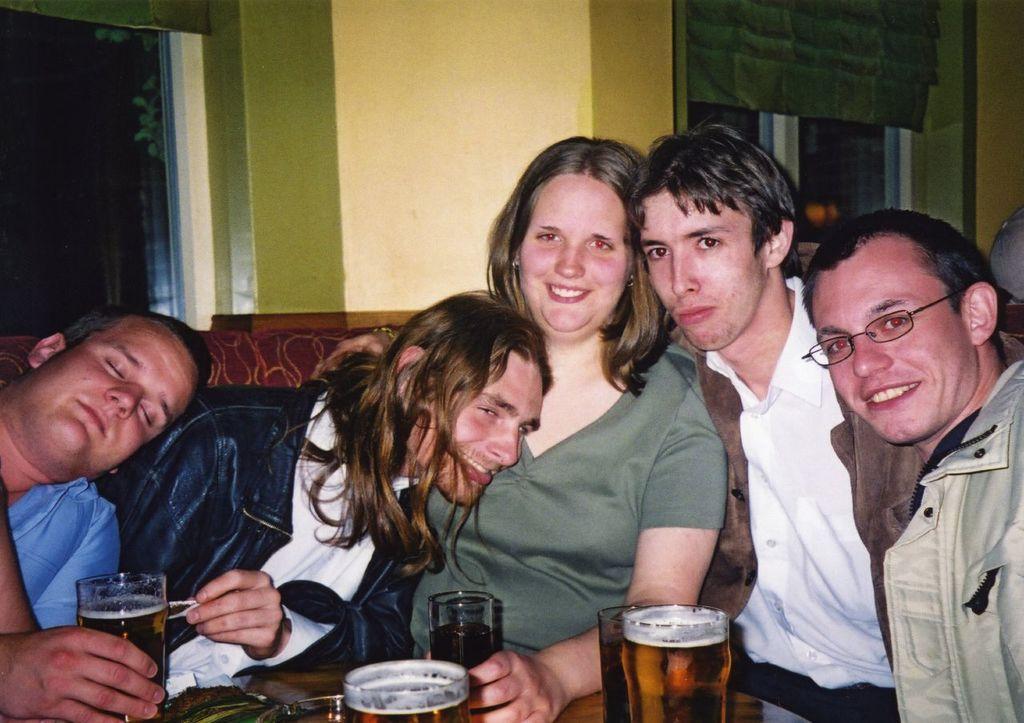Describe this image in one or two sentences. This picture shows a group of people seated and we see few glasses on the table 